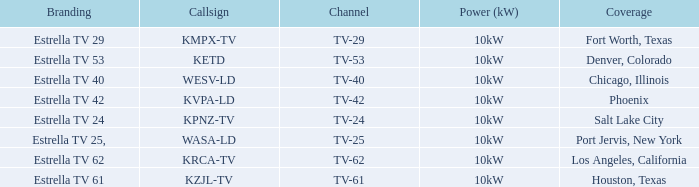Which city did kpnz-tv provide coverage for? Salt Lake City. Would you be able to parse every entry in this table? {'header': ['Branding', 'Callsign', 'Channel', 'Power (kW)', 'Coverage'], 'rows': [['Estrella TV 29', 'KMPX-TV', 'TV-29', '10kW', 'Fort Worth, Texas'], ['Estrella TV 53', 'KETD', 'TV-53', '10kW', 'Denver, Colorado'], ['Estrella TV 40', 'WESV-LD', 'TV-40', '10kW', 'Chicago, Illinois'], ['Estrella TV 42', 'KVPA-LD', 'TV-42', '10kW', 'Phoenix'], ['Estrella TV 24', 'KPNZ-TV', 'TV-24', '10kW', 'Salt Lake City'], ['Estrella TV 25,', 'WASA-LD', 'TV-25', '10kW', 'Port Jervis, New York'], ['Estrella TV 62', 'KRCA-TV', 'TV-62', '10kW', 'Los Angeles, California'], ['Estrella TV 61', 'KZJL-TV', 'TV-61', '10kW', 'Houston, Texas']]} 